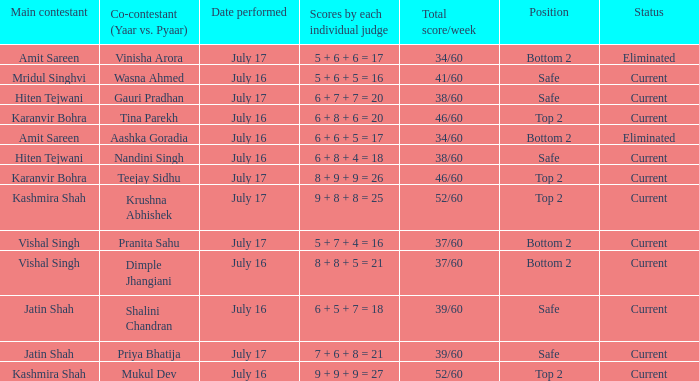What position did Pranita Sahu's team get? Bottom 2. Could you help me parse every detail presented in this table? {'header': ['Main contestant', 'Co-contestant (Yaar vs. Pyaar)', 'Date performed', 'Scores by each individual judge', 'Total score/week', 'Position', 'Status'], 'rows': [['Amit Sareen', 'Vinisha Arora', 'July 17', '5 + 6 + 6 = 17', '34/60', 'Bottom 2', 'Eliminated'], ['Mridul Singhvi', 'Wasna Ahmed', 'July 16', '5 + 6 + 5 = 16', '41/60', 'Safe', 'Current'], ['Hiten Tejwani', 'Gauri Pradhan', 'July 17', '6 + 7 + 7 = 20', '38/60', 'Safe', 'Current'], ['Karanvir Bohra', 'Tina Parekh', 'July 16', '6 + 8 + 6 = 20', '46/60', 'Top 2', 'Current'], ['Amit Sareen', 'Aashka Goradia', 'July 16', '6 + 6 + 5 = 17', '34/60', 'Bottom 2', 'Eliminated'], ['Hiten Tejwani', 'Nandini Singh', 'July 16', '6 + 8 + 4 = 18', '38/60', 'Safe', 'Current'], ['Karanvir Bohra', 'Teejay Sidhu', 'July 17', '8 + 9 + 9 = 26', '46/60', 'Top 2', 'Current'], ['Kashmira Shah', 'Krushna Abhishek', 'July 17', '9 + 8 + 8 = 25', '52/60', 'Top 2', 'Current'], ['Vishal Singh', 'Pranita Sahu', 'July 17', '5 + 7 + 4 = 16', '37/60', 'Bottom 2', 'Current'], ['Vishal Singh', 'Dimple Jhangiani', 'July 16', '8 + 8 + 5 = 21', '37/60', 'Bottom 2', 'Current'], ['Jatin Shah', 'Shalini Chandran', 'July 16', '6 + 5 + 7 = 18', '39/60', 'Safe', 'Current'], ['Jatin Shah', 'Priya Bhatija', 'July 17', '7 + 6 + 8 = 21', '39/60', 'Safe', 'Current'], ['Kashmira Shah', 'Mukul Dev', 'July 16', '9 + 9 + 9 = 27', '52/60', 'Top 2', 'Current']]} 